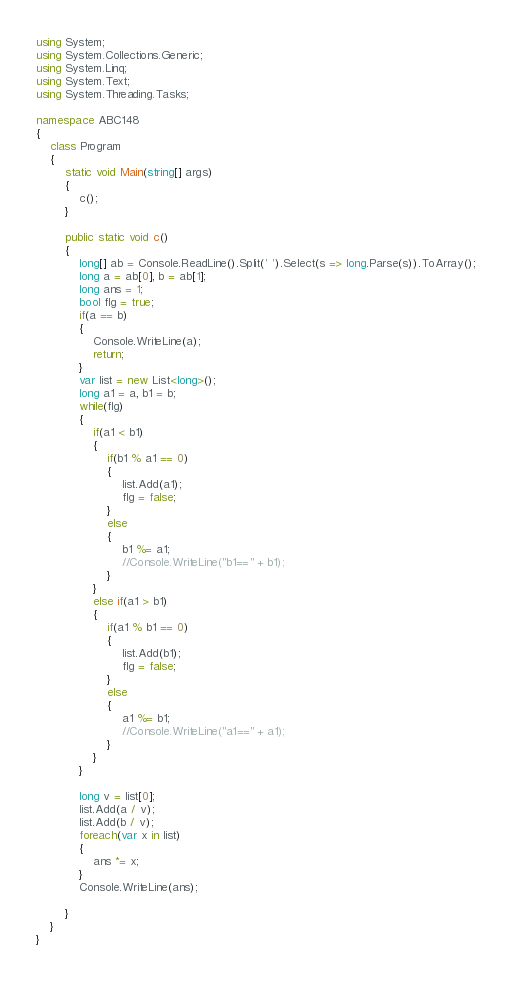<code> <loc_0><loc_0><loc_500><loc_500><_C#_>using System;
using System.Collections.Generic;
using System.Linq;
using System.Text;
using System.Threading.Tasks;

namespace ABC148
{
    class Program
    {
        static void Main(string[] args)
        {
            c();
        }
        
        public static void c()
        {
            long[] ab = Console.ReadLine().Split(' ').Select(s => long.Parse(s)).ToArray();
            long a = ab[0], b = ab[1];
            long ans = 1;
            bool flg = true;
            if(a == b)
            {
                Console.WriteLine(a);
                return;
            }
            var list = new List<long>();
            long a1 = a, b1 = b;
            while(flg)
            {
                if(a1 < b1)
                {
                    if(b1 % a1 == 0)
                    {
                        list.Add(a1);
                        flg = false;
                    }
                    else
                    {
                        b1 %= a1;
                        //Console.WriteLine("b1==" + b1);
                    }
                }
                else if(a1 > b1)
                {
                    if(a1 % b1 == 0)
                    {
                        list.Add(b1);
                        flg = false;
                    }
                    else
                    {
                        a1 %= b1;
                        //Console.WriteLine("a1==" + a1);
                    }
                }
            }
            
            long v = list[0];
            list.Add(a / v);
            list.Add(b / v); 
            foreach(var x in list)
            {
                ans *= x;
            }
            Console.WriteLine(ans);
            
        }
    }
}
</code> 